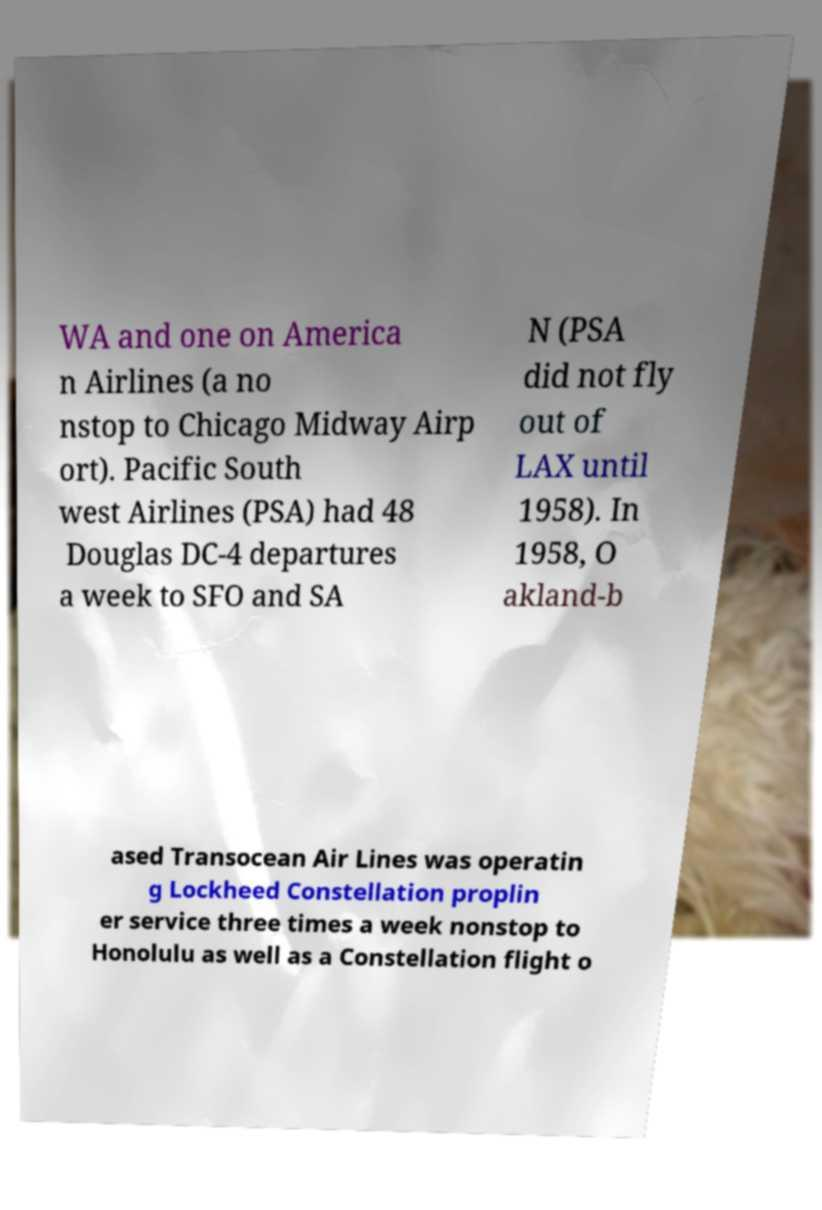Please identify and transcribe the text found in this image. WA and one on America n Airlines (a no nstop to Chicago Midway Airp ort). Pacific South west Airlines (PSA) had 48 Douglas DC-4 departures a week to SFO and SA N (PSA did not fly out of LAX until 1958). In 1958, O akland-b ased Transocean Air Lines was operatin g Lockheed Constellation proplin er service three times a week nonstop to Honolulu as well as a Constellation flight o 